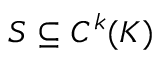Convert formula to latex. <formula><loc_0><loc_0><loc_500><loc_500>S \subseteq C ^ { k } ( K )</formula> 